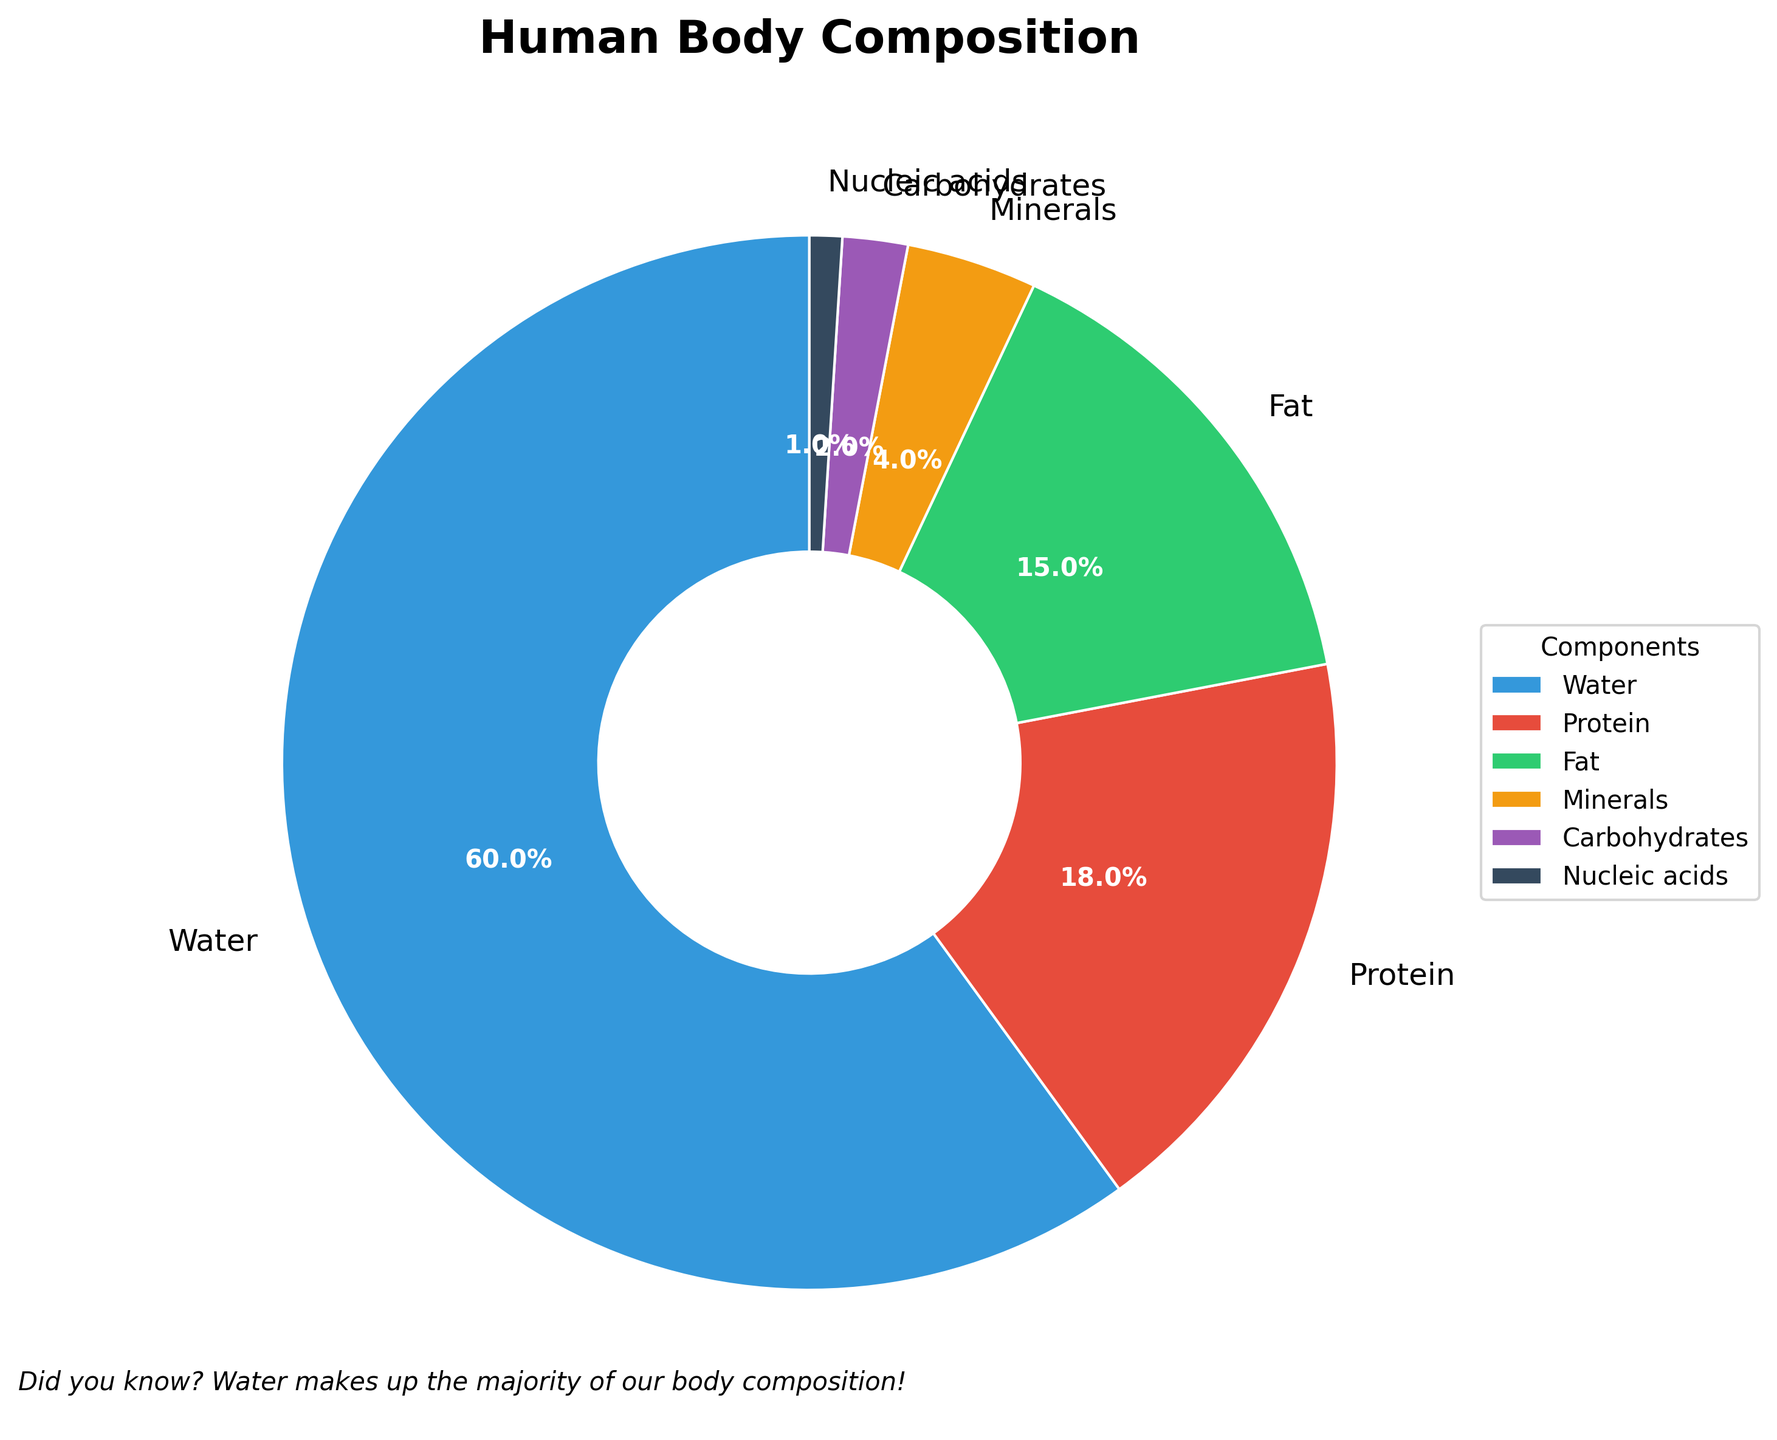Which component makes up the majority of the human body composition? The pie chart shows the breakdown of the human body composition by major components. The component with the largest percentage is water, making up 60% of the body composition.
Answer: Water What is the combined percentage of protein and fat in the human body? To find the combined percentage of protein and fat, add their individual percentages from the pie chart: protein (18%) + fat (15%) = 33%.
Answer: 33% Which component has a larger percentage, minerals or carbohydrates? By comparing the percentages shown in the pie chart, minerals account for 4% while carbohydrates account for 2%. Therefore, minerals have a larger percentage.
Answer: Minerals What percentage of the human body is composed of nucleic acids? The pie chart lists nucleic acids as making up 1% of the human body composition.
Answer: 1% By how much does the percentage of water exceed the percentage of fat? The percentage of water is 60%, and the percentage of fat is 15%. The difference is calculated as 60% - 15% = 45%.
Answer: 45% What is the total percentage of the human body composition attributed to water, protein, and fat combined? Adding up the percentages of water, protein, and fat from the pie chart gives: 60% (water) + 18% (protein) + 15% (fat) = 93%.
Answer: 93% Is the percentage of carbohydrates in the human body composition greater than nucleic acids? Comparing the pie chart percentages, carbohydrates make up 2% while nucleic acids make up 1%. Therefore, carbohydrates have a greater percentage.
Answer: Yes Which component is represented by the smallest wedge in the pie chart? The smallest wedge in the pie chart corresponds to the component with the smallest percentage. Nucleic acids make up 1%, which is the smallest percentage.
Answer: Nucleic acids What is the difference in percentage between protein and minerals? The percentage of protein is 18% and the percentage of minerals is 4%. The difference is calculated as 18% - 4% = 14%.
Answer: 14% 